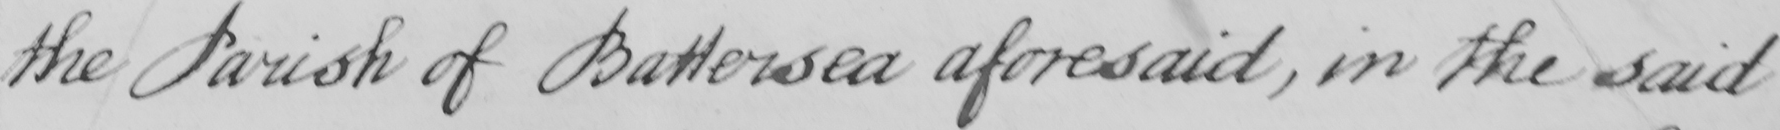Please transcribe the handwritten text in this image. the Parish of Battersea aforesaid , in the said 